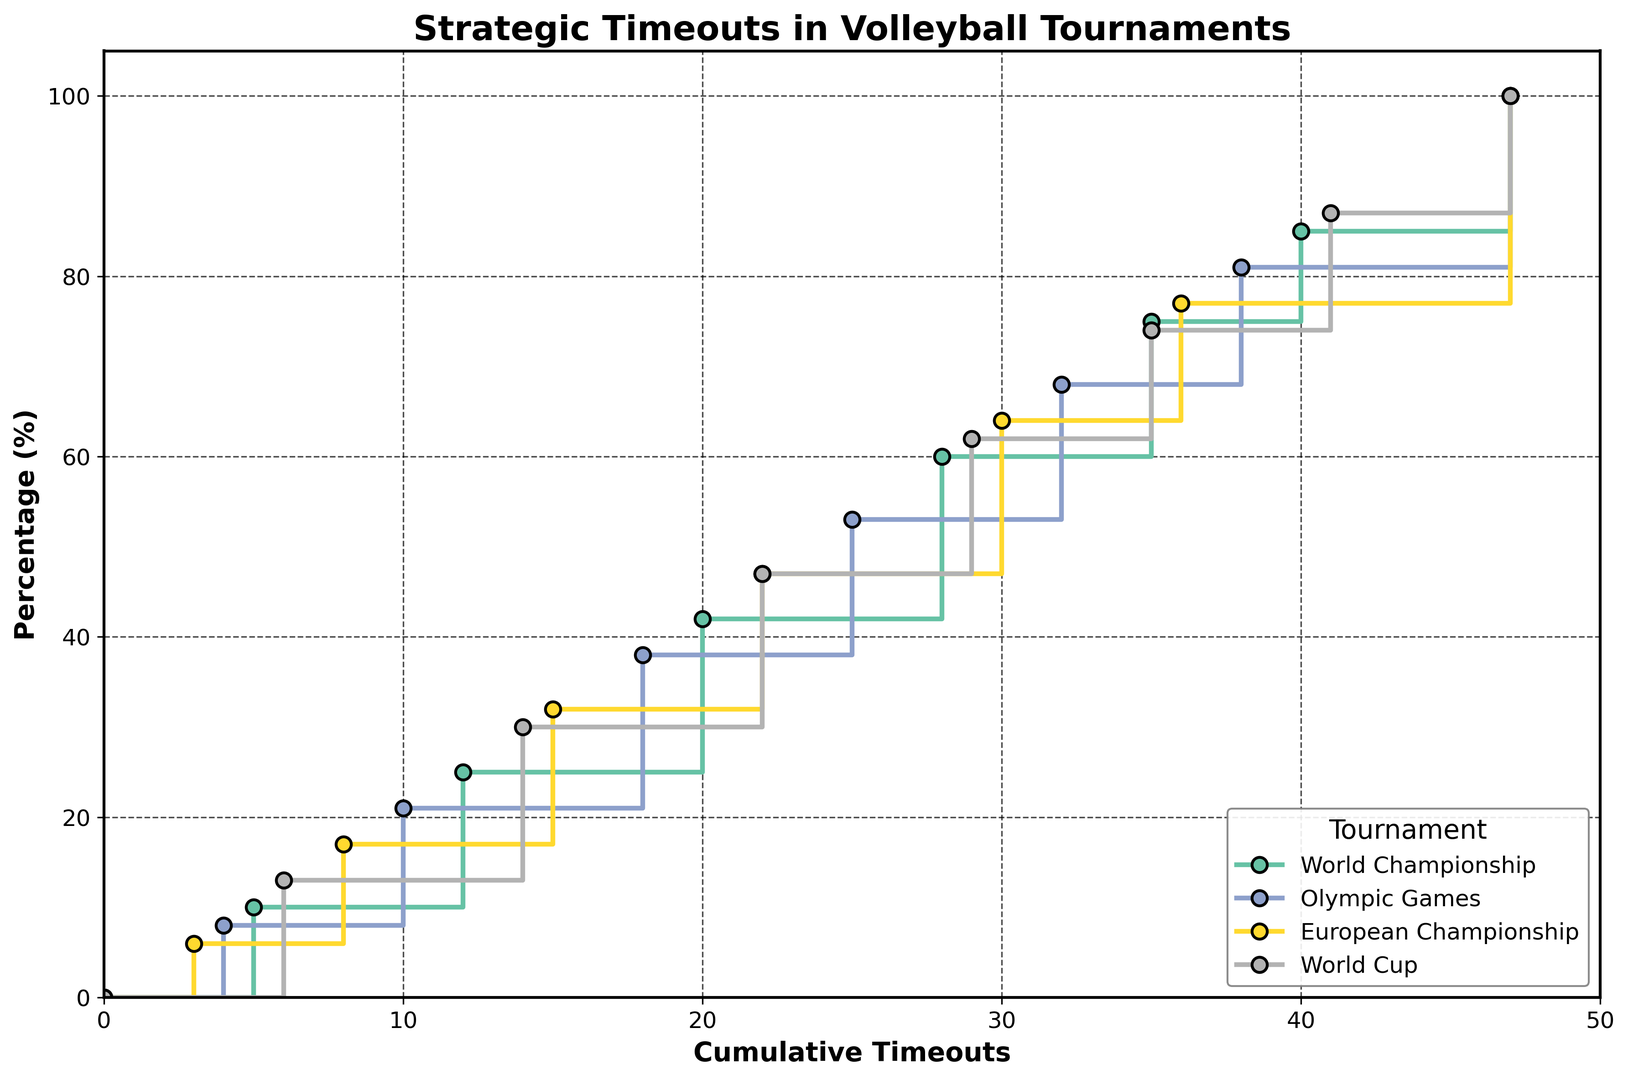What tournament had the steepest increase in the percentage of timeouts used between 10 and 25 cumulative timeouts? To determine the steepest increase, compare the percentage differences between 10 and 25 cumulative timeouts for all tournaments. The increases are: 
- World Championship: \(42\% - 25\% = 17\%\)
- Olympic Games: \(53\% - 21\% = 32\%\)
- European Championship: \(32\% - 17\% = 15\%\)
- World Cup: \(47\% - 30\% = 17\%\)
The Olympic Games has the steepest increase in this range.
Answer: Olympic Games Which tournament reaches 100% utilization of timeouts the quickest in terms of cumulative timeouts? Identify the cumulative timeouts at which each tournament reaches 100%. All tournaments reach 100% at 47 cumulative timeouts, so they reach it concurrently.
Answer: All tournaments At how many cumulative timeouts does the World Cup reach 30% of the timeouts used? Check the data points for the World Cup where the percentage is 30. This occurs at 14 cumulative timeouts.
Answer: 14 What is the difference in the percentage of timeouts used between the World Championship and European Championship at 22 cumulative timeouts? Look at the tournament curves at 22 cumulative timeouts. 
- World Championship: 42%
- European Championship: 47%
The difference is \(47\% - 42\% = 5\%\).
Answer: 5% Which tournament has the longest interval between reaching 60% and 75% of the timeouts used? Identify the cumulative timeouts at which the tournaments reach 60% and 75% and calculate the differences:
- World Championship: \(35 - 28 = 7\)
- Olympic Games: \(32 - 25 = 7\)
- European Championship: \(30 - 22 = 8\)
- World Cup: \(35 - 29 = 6\)
The European Championship has the longest interval with 8 cumulative timeouts.
Answer: European Championship 